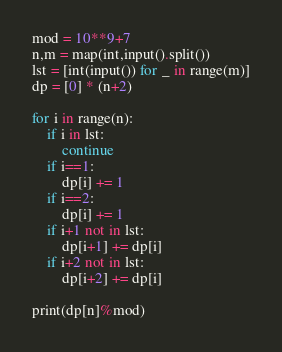Convert code to text. <code><loc_0><loc_0><loc_500><loc_500><_Python_>mod = 10**9+7
n,m = map(int,input().split())
lst = [int(input()) for _ in range(m)]
dp = [0] * (n+2)

for i in range(n):
    if i in lst:
        continue
    if i==1:
        dp[i] += 1
    if i==2:
        dp[i] += 1
    if i+1 not in lst:
        dp[i+1] += dp[i]
    if i+2 not in lst:
        dp[i+2] += dp[i]

print(dp[n]%mod)</code> 